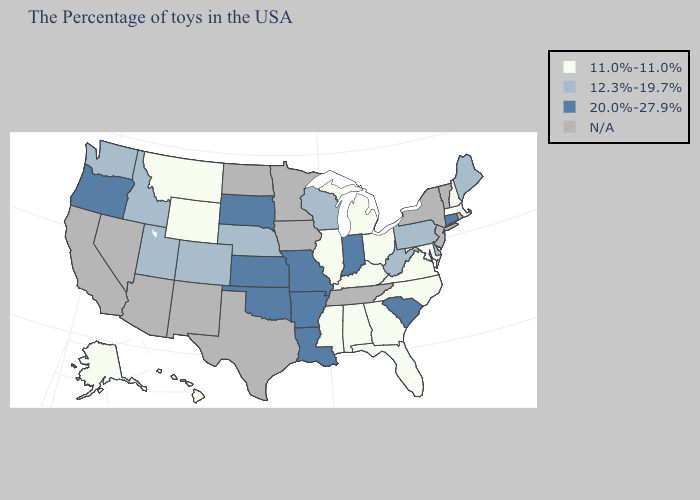Does New Hampshire have the lowest value in the Northeast?
Short answer required. Yes. Name the states that have a value in the range 12.3%-19.7%?
Keep it brief. Maine, Delaware, Pennsylvania, West Virginia, Wisconsin, Nebraska, Colorado, Utah, Idaho, Washington. Which states have the lowest value in the South?
Write a very short answer. Maryland, Virginia, North Carolina, Florida, Georgia, Kentucky, Alabama, Mississippi. Name the states that have a value in the range 12.3%-19.7%?
Give a very brief answer. Maine, Delaware, Pennsylvania, West Virginia, Wisconsin, Nebraska, Colorado, Utah, Idaho, Washington. Is the legend a continuous bar?
Concise answer only. No. Name the states that have a value in the range 11.0%-11.0%?
Give a very brief answer. Massachusetts, New Hampshire, Maryland, Virginia, North Carolina, Ohio, Florida, Georgia, Michigan, Kentucky, Alabama, Illinois, Mississippi, Wyoming, Montana, Alaska, Hawaii. What is the highest value in states that border Indiana?
Write a very short answer. 11.0%-11.0%. Which states hav the highest value in the West?
Quick response, please. Oregon. What is the value of Delaware?
Be succinct. 12.3%-19.7%. Name the states that have a value in the range 12.3%-19.7%?
Write a very short answer. Maine, Delaware, Pennsylvania, West Virginia, Wisconsin, Nebraska, Colorado, Utah, Idaho, Washington. What is the value of Washington?
Quick response, please. 12.3%-19.7%. How many symbols are there in the legend?
Be succinct. 4. What is the value of New Jersey?
Answer briefly. N/A. Name the states that have a value in the range 11.0%-11.0%?
Give a very brief answer. Massachusetts, New Hampshire, Maryland, Virginia, North Carolina, Ohio, Florida, Georgia, Michigan, Kentucky, Alabama, Illinois, Mississippi, Wyoming, Montana, Alaska, Hawaii. What is the value of New Jersey?
Write a very short answer. N/A. 